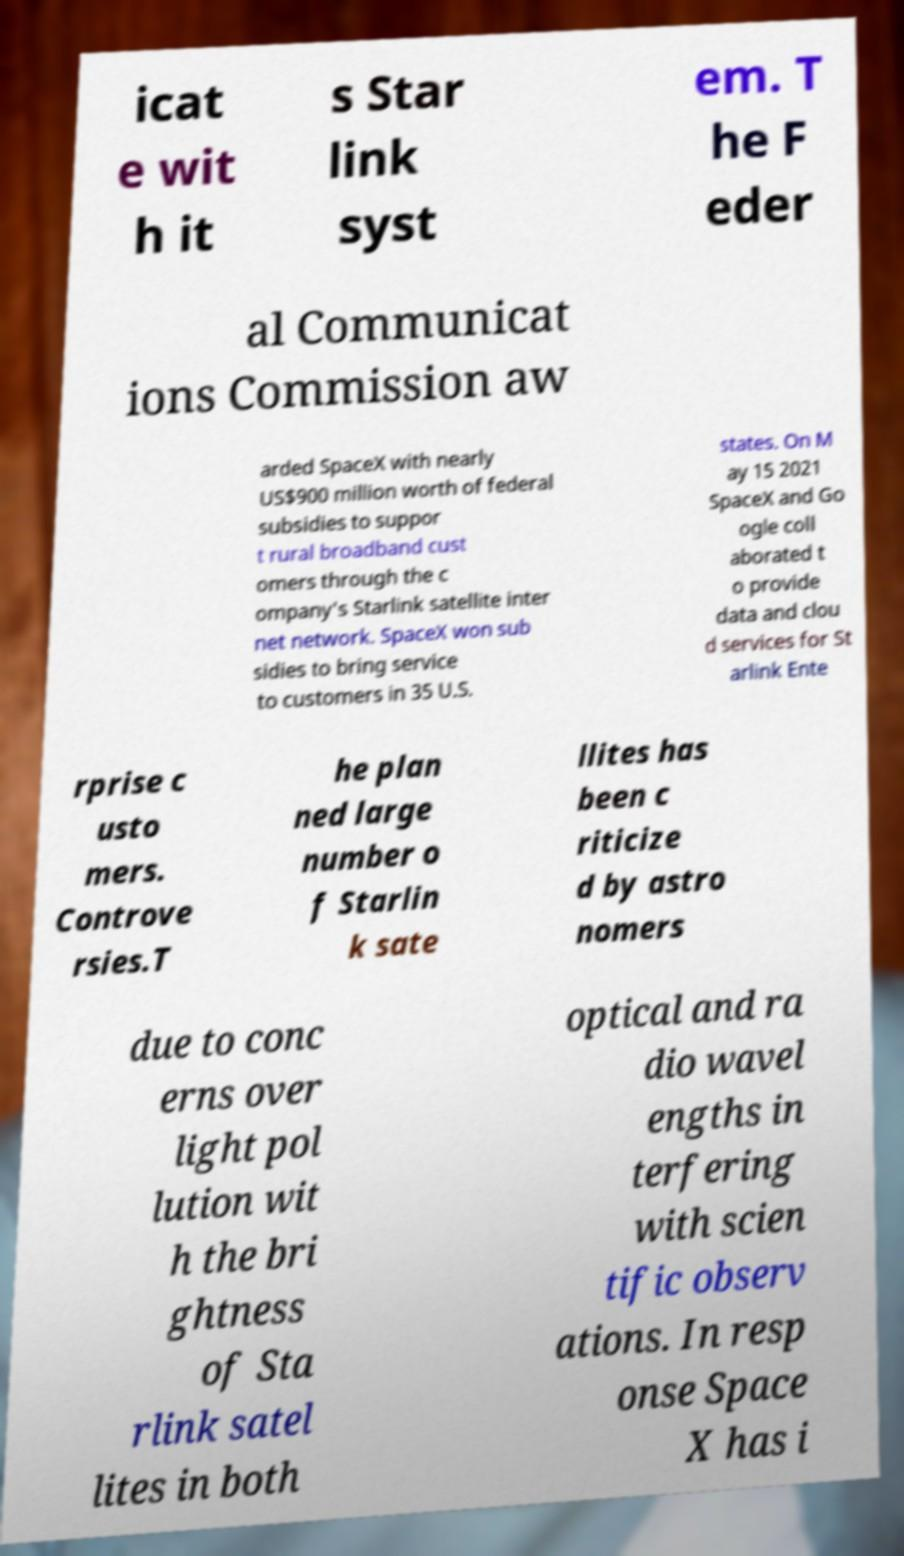For documentation purposes, I need the text within this image transcribed. Could you provide that? icat e wit h it s Star link syst em. T he F eder al Communicat ions Commission aw arded SpaceX with nearly US$900 million worth of federal subsidies to suppor t rural broadband cust omers through the c ompany's Starlink satellite inter net network. SpaceX won sub sidies to bring service to customers in 35 U.S. states. On M ay 15 2021 SpaceX and Go ogle coll aborated t o provide data and clou d services for St arlink Ente rprise c usto mers. Controve rsies.T he plan ned large number o f Starlin k sate llites has been c riticize d by astro nomers due to conc erns over light pol lution wit h the bri ghtness of Sta rlink satel lites in both optical and ra dio wavel engths in terfering with scien tific observ ations. In resp onse Space X has i 